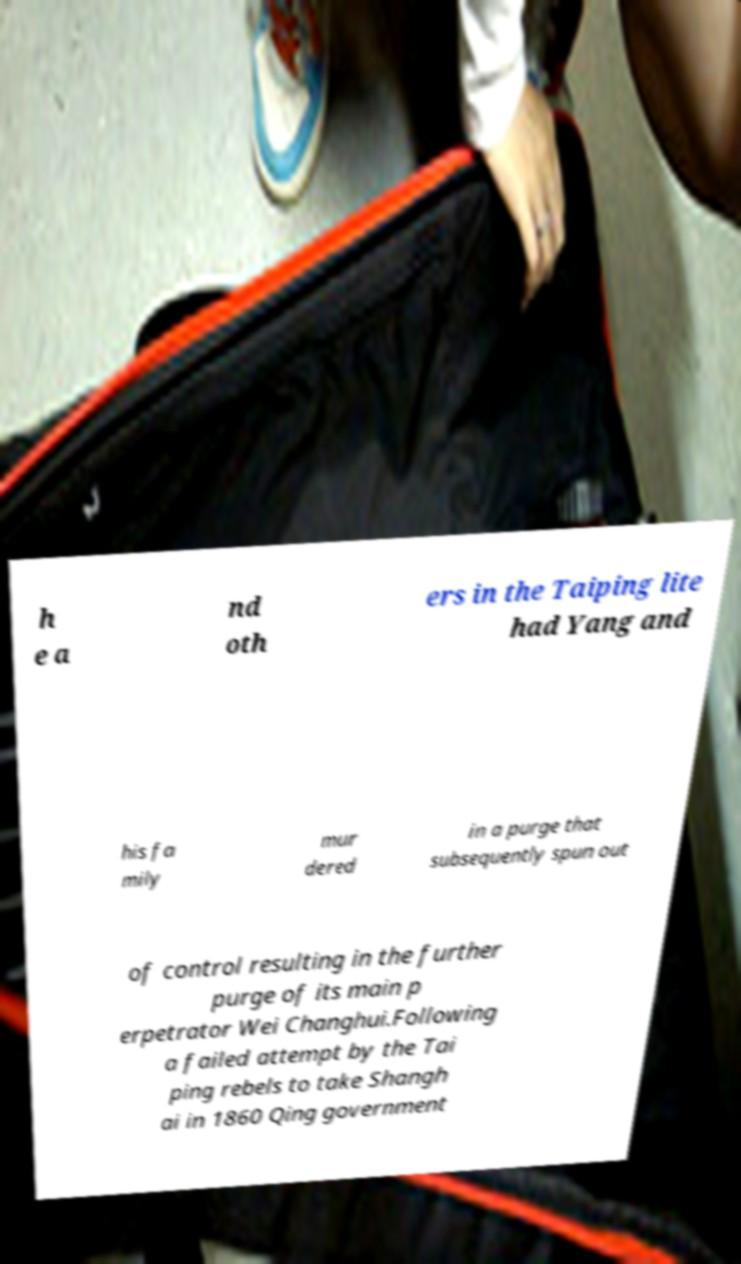I need the written content from this picture converted into text. Can you do that? h e a nd oth ers in the Taiping lite had Yang and his fa mily mur dered in a purge that subsequently spun out of control resulting in the further purge of its main p erpetrator Wei Changhui.Following a failed attempt by the Tai ping rebels to take Shangh ai in 1860 Qing government 